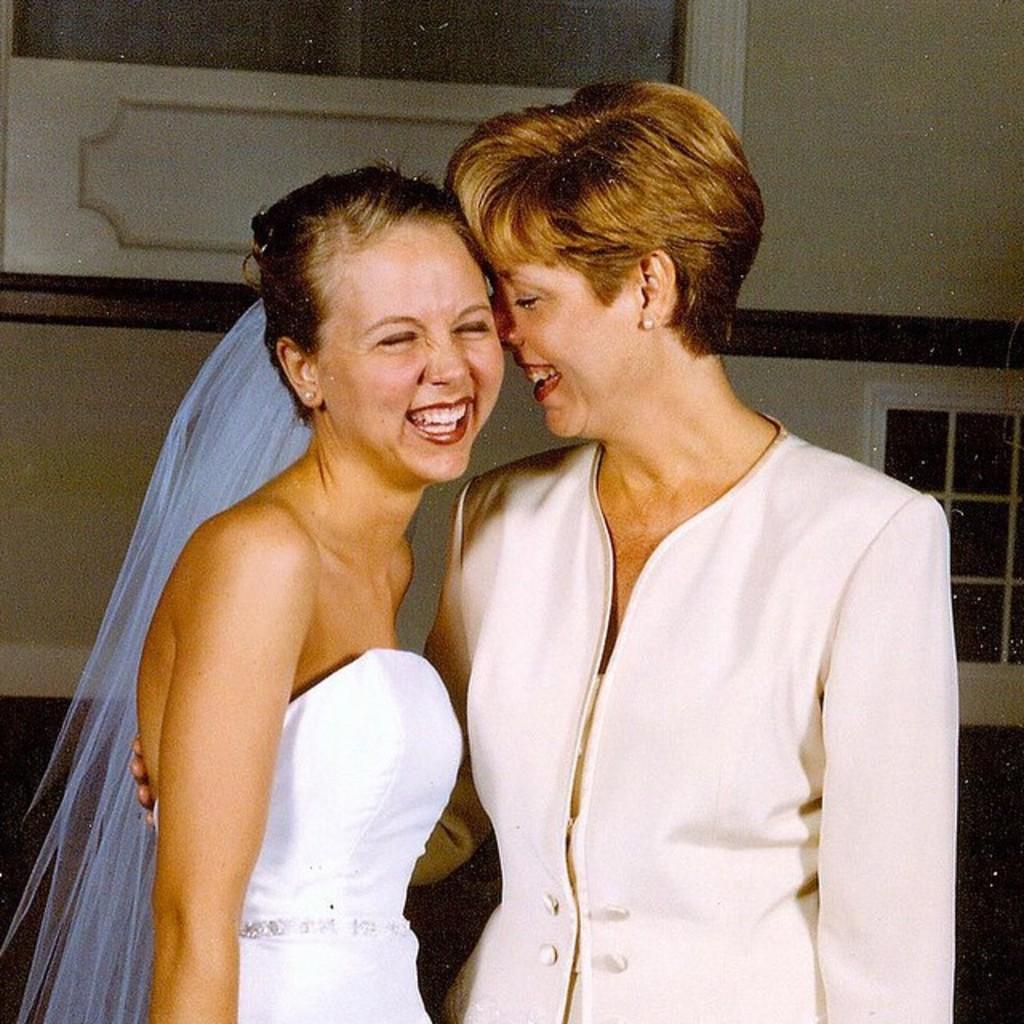Describe this image in one or two sentences. In this image I can see two persons standing. The person at left is wearing white color dress and the person at right is wearing cream color dress. In the background I can see the window and the wall is in cream color. 